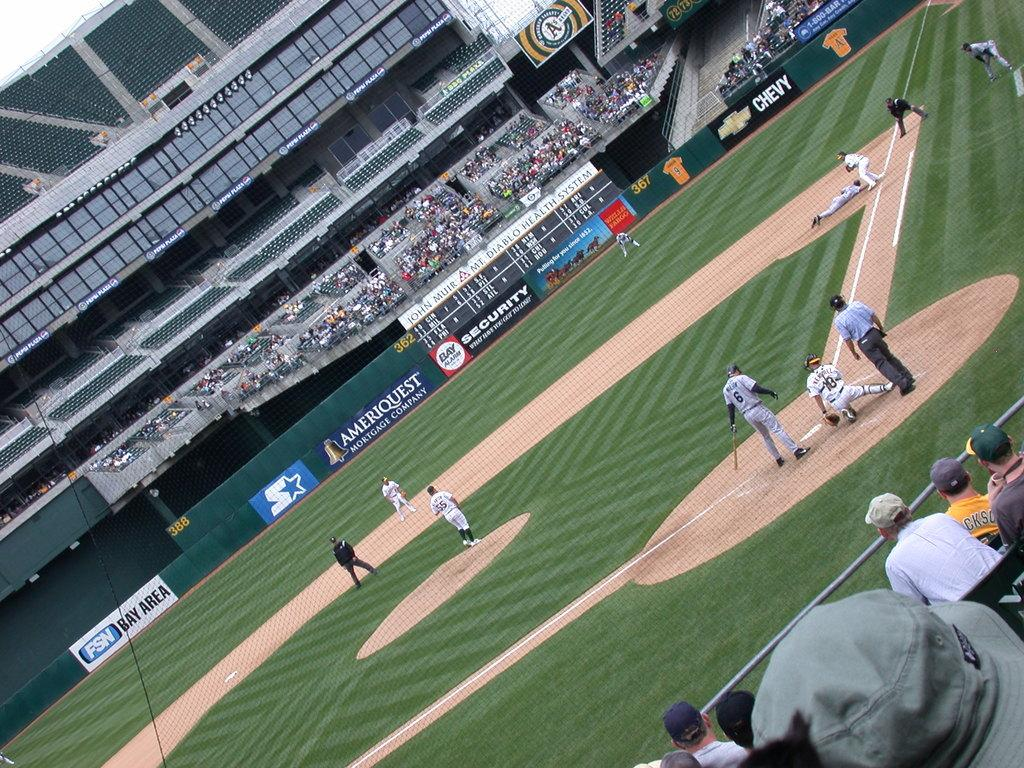<image>
Create a compact narrative representing the image presented. Ameriquest is advertised in the background of the baseball field. 